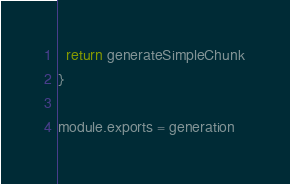<code> <loc_0><loc_0><loc_500><loc_500><_JavaScript_>  return generateSimpleChunk
}

module.exports = generation
</code> 